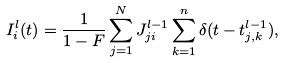Convert formula to latex. <formula><loc_0><loc_0><loc_500><loc_500>I ^ { l } _ { i } ( t ) & = \frac { 1 } { 1 - F } \sum ^ { N } _ { j = 1 } J ^ { l - 1 } _ { j i } \sum ^ { n } _ { k = 1 } \delta ( t - t ^ { l - 1 } _ { j , k } ) ,</formula> 